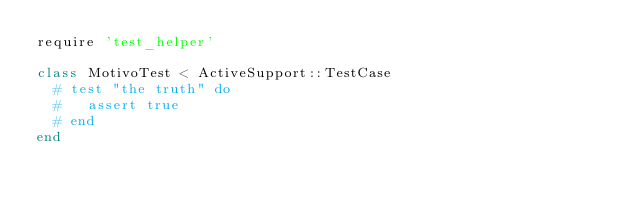<code> <loc_0><loc_0><loc_500><loc_500><_Ruby_>require 'test_helper'

class MotivoTest < ActiveSupport::TestCase
  # test "the truth" do
  #   assert true
  # end
end
</code> 